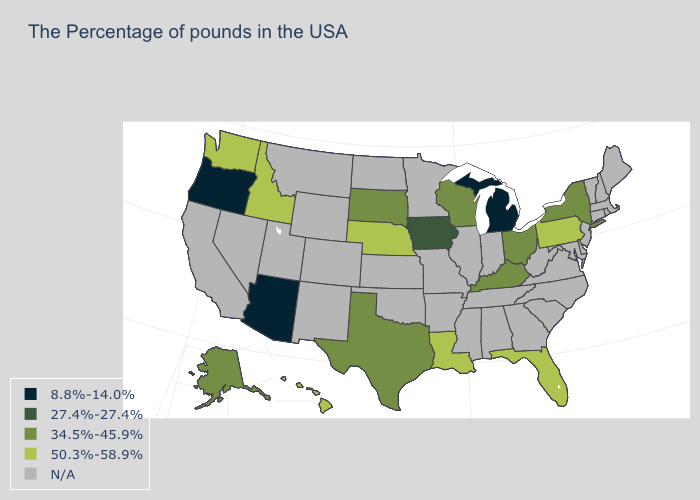What is the highest value in the USA?
Quick response, please. 50.3%-58.9%. What is the lowest value in the USA?
Concise answer only. 8.8%-14.0%. Which states have the lowest value in the USA?
Write a very short answer. Michigan, Arizona, Oregon. What is the value of Tennessee?
Short answer required. N/A. Among the states that border Iowa , does Nebraska have the highest value?
Be succinct. Yes. What is the value of Vermont?
Quick response, please. N/A. What is the value of New York?
Keep it brief. 34.5%-45.9%. What is the lowest value in the USA?
Give a very brief answer. 8.8%-14.0%. Among the states that border Nevada , does Arizona have the highest value?
Write a very short answer. No. Which states have the lowest value in the USA?
Short answer required. Michigan, Arizona, Oregon. Among the states that border Texas , which have the lowest value?
Keep it brief. Louisiana. What is the value of Rhode Island?
Give a very brief answer. N/A. Which states have the highest value in the USA?
Keep it brief. Pennsylvania, Florida, Louisiana, Nebraska, Idaho, Washington, Hawaii. 